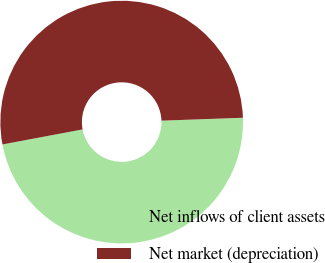Convert chart. <chart><loc_0><loc_0><loc_500><loc_500><pie_chart><fcel>Net inflows of client assets<fcel>Net market (depreciation)<nl><fcel>47.62%<fcel>52.38%<nl></chart> 